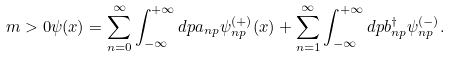<formula> <loc_0><loc_0><loc_500><loc_500>m > 0 \psi ( x ) = \sum _ { n = 0 } ^ { \infty } \int _ { - \infty } ^ { + \infty } d p a _ { n p } \psi _ { n p } ^ { ( + ) } ( x ) + \sum _ { n = 1 } ^ { \infty } \int _ { - \infty } ^ { + \infty } d p b _ { n p } ^ { \dag } \psi _ { n p } ^ { ( - ) } .</formula> 